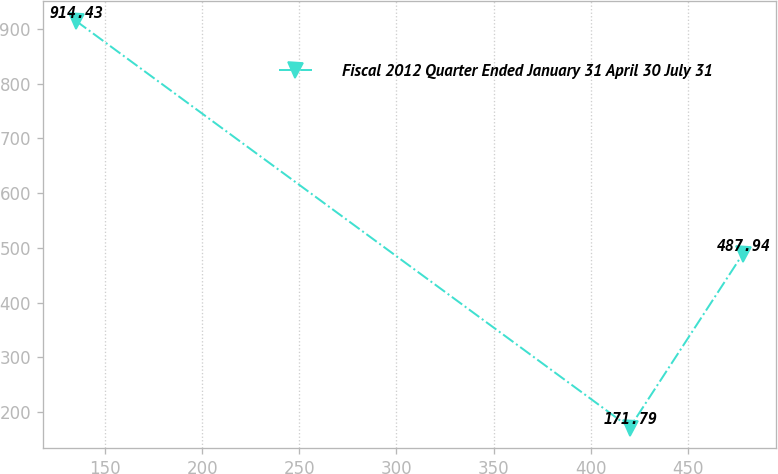<chart> <loc_0><loc_0><loc_500><loc_500><line_chart><ecel><fcel>Fiscal 2012 Quarter Ended January 31 April 30 July 31<nl><fcel>135.06<fcel>914.43<nl><fcel>420.04<fcel>171.79<nl><fcel>478.04<fcel>487.94<nl></chart> 